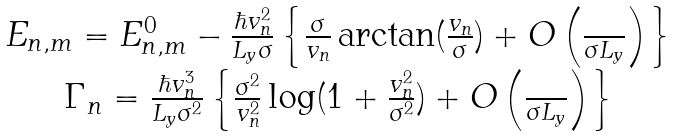Convert formula to latex. <formula><loc_0><loc_0><loc_500><loc_500>\begin{array} { c } E _ { n , m } = E ^ { 0 } _ { n , m } - \frac { \hbar { v } _ { n } ^ { 2 } } { L _ { y } \sigma } \left \{ \frac { \sigma } { v _ { n } } \arctan ( \frac { v _ { n } } { \sigma } ) + O \left ( \frac { } { \sigma L _ { y } } \right ) \right \} \\ \Gamma _ { n } = \frac { \hbar { v } _ { n } ^ { 3 } } { L _ { y } \sigma ^ { 2 } } \left \{ \frac { \sigma ^ { 2 } } { v _ { n } ^ { 2 } } \log ( 1 + \frac { v _ { n } ^ { 2 } } { \sigma ^ { 2 } } ) + O \left ( \frac { } { \sigma L _ { y } } \right ) \right \} \\ \end{array}</formula> 